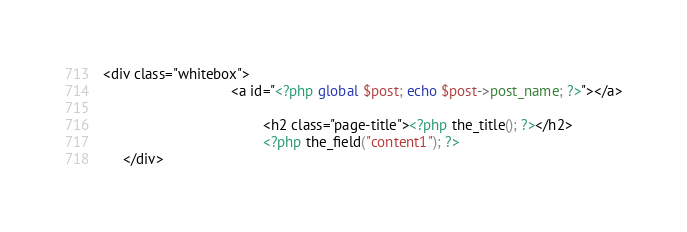<code> <loc_0><loc_0><loc_500><loc_500><_PHP_><div class="whitebox">
                                <a id="<?php global $post; echo $post->post_name; ?>"></a>
                                     
                                        <h2 class="page-title"><?php the_title(); ?></h2>    
                                        <?php the_field("content1"); ?>
     </div>                                  
</code> 